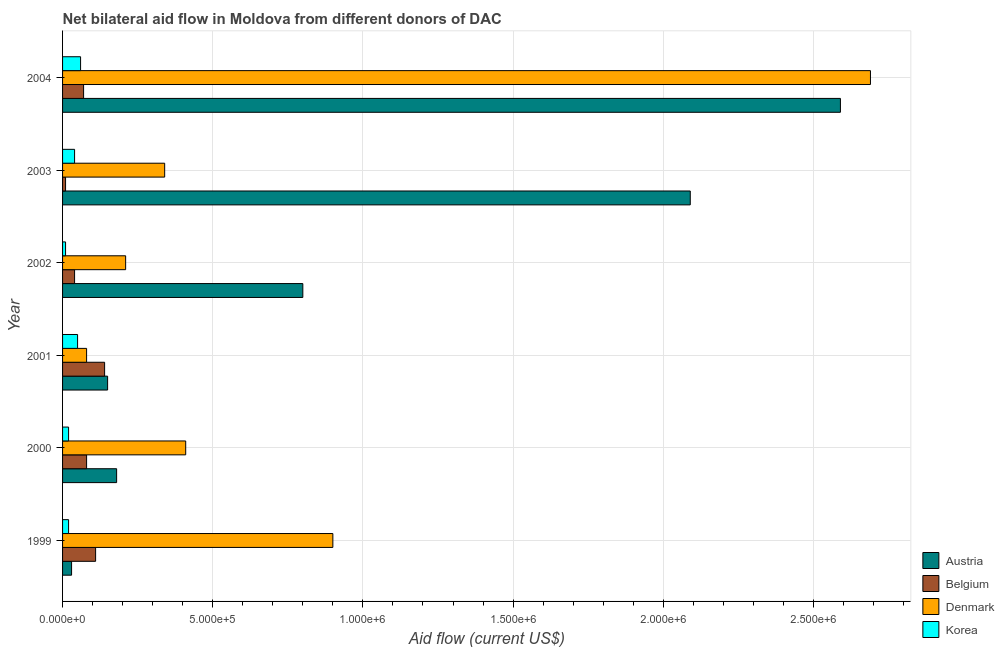How many bars are there on the 3rd tick from the top?
Your response must be concise. 4. What is the label of the 3rd group of bars from the top?
Your response must be concise. 2002. In how many cases, is the number of bars for a given year not equal to the number of legend labels?
Keep it short and to the point. 0. What is the amount of aid given by austria in 2002?
Make the answer very short. 8.00e+05. Across all years, what is the maximum amount of aid given by austria?
Your response must be concise. 2.59e+06. Across all years, what is the minimum amount of aid given by belgium?
Offer a very short reply. 10000. In which year was the amount of aid given by denmark maximum?
Provide a succinct answer. 2004. What is the total amount of aid given by korea in the graph?
Offer a terse response. 2.00e+05. What is the difference between the amount of aid given by denmark in 1999 and that in 2002?
Give a very brief answer. 6.90e+05. What is the difference between the amount of aid given by belgium in 2004 and the amount of aid given by denmark in 2002?
Provide a succinct answer. -1.40e+05. What is the average amount of aid given by belgium per year?
Your answer should be very brief. 7.50e+04. In the year 2004, what is the difference between the amount of aid given by belgium and amount of aid given by austria?
Provide a short and direct response. -2.52e+06. Is the difference between the amount of aid given by denmark in 1999 and 2004 greater than the difference between the amount of aid given by belgium in 1999 and 2004?
Your answer should be very brief. No. What is the difference between the highest and the second highest amount of aid given by denmark?
Give a very brief answer. 1.79e+06. What is the difference between the highest and the lowest amount of aid given by austria?
Keep it short and to the point. 2.56e+06. Is it the case that in every year, the sum of the amount of aid given by belgium and amount of aid given by austria is greater than the sum of amount of aid given by korea and amount of aid given by denmark?
Offer a very short reply. No. What does the 1st bar from the bottom in 1999 represents?
Offer a terse response. Austria. Is it the case that in every year, the sum of the amount of aid given by austria and amount of aid given by belgium is greater than the amount of aid given by denmark?
Offer a very short reply. No. Are the values on the major ticks of X-axis written in scientific E-notation?
Your answer should be very brief. Yes. Where does the legend appear in the graph?
Give a very brief answer. Bottom right. How many legend labels are there?
Make the answer very short. 4. How are the legend labels stacked?
Keep it short and to the point. Vertical. What is the title of the graph?
Give a very brief answer. Net bilateral aid flow in Moldova from different donors of DAC. Does "Oil" appear as one of the legend labels in the graph?
Your answer should be very brief. No. What is the label or title of the Y-axis?
Offer a terse response. Year. What is the Aid flow (current US$) in Austria in 1999?
Your response must be concise. 3.00e+04. What is the Aid flow (current US$) of Belgium in 1999?
Offer a very short reply. 1.10e+05. What is the Aid flow (current US$) in Denmark in 1999?
Provide a succinct answer. 9.00e+05. What is the Aid flow (current US$) of Belgium in 2000?
Your answer should be very brief. 8.00e+04. What is the Aid flow (current US$) in Denmark in 2000?
Your answer should be compact. 4.10e+05. What is the Aid flow (current US$) of Belgium in 2001?
Your answer should be very brief. 1.40e+05. What is the Aid flow (current US$) of Denmark in 2001?
Provide a succinct answer. 8.00e+04. What is the Aid flow (current US$) of Korea in 2001?
Provide a short and direct response. 5.00e+04. What is the Aid flow (current US$) in Austria in 2002?
Offer a very short reply. 8.00e+05. What is the Aid flow (current US$) of Belgium in 2002?
Offer a terse response. 4.00e+04. What is the Aid flow (current US$) of Korea in 2002?
Ensure brevity in your answer.  10000. What is the Aid flow (current US$) in Austria in 2003?
Ensure brevity in your answer.  2.09e+06. What is the Aid flow (current US$) of Denmark in 2003?
Give a very brief answer. 3.40e+05. What is the Aid flow (current US$) in Korea in 2003?
Offer a very short reply. 4.00e+04. What is the Aid flow (current US$) in Austria in 2004?
Offer a very short reply. 2.59e+06. What is the Aid flow (current US$) of Belgium in 2004?
Provide a succinct answer. 7.00e+04. What is the Aid flow (current US$) in Denmark in 2004?
Make the answer very short. 2.69e+06. What is the Aid flow (current US$) of Korea in 2004?
Your response must be concise. 6.00e+04. Across all years, what is the maximum Aid flow (current US$) in Austria?
Offer a very short reply. 2.59e+06. Across all years, what is the maximum Aid flow (current US$) of Denmark?
Ensure brevity in your answer.  2.69e+06. Across all years, what is the maximum Aid flow (current US$) in Korea?
Your answer should be compact. 6.00e+04. Across all years, what is the minimum Aid flow (current US$) in Austria?
Keep it short and to the point. 3.00e+04. Across all years, what is the minimum Aid flow (current US$) in Denmark?
Provide a short and direct response. 8.00e+04. Across all years, what is the minimum Aid flow (current US$) in Korea?
Provide a short and direct response. 10000. What is the total Aid flow (current US$) of Austria in the graph?
Your answer should be very brief. 5.84e+06. What is the total Aid flow (current US$) in Denmark in the graph?
Provide a succinct answer. 4.63e+06. What is the difference between the Aid flow (current US$) of Austria in 1999 and that in 2000?
Give a very brief answer. -1.50e+05. What is the difference between the Aid flow (current US$) of Korea in 1999 and that in 2000?
Offer a terse response. 0. What is the difference between the Aid flow (current US$) of Austria in 1999 and that in 2001?
Your answer should be compact. -1.20e+05. What is the difference between the Aid flow (current US$) of Belgium in 1999 and that in 2001?
Make the answer very short. -3.00e+04. What is the difference between the Aid flow (current US$) in Denmark in 1999 and that in 2001?
Your answer should be very brief. 8.20e+05. What is the difference between the Aid flow (current US$) of Korea in 1999 and that in 2001?
Give a very brief answer. -3.00e+04. What is the difference between the Aid flow (current US$) in Austria in 1999 and that in 2002?
Offer a terse response. -7.70e+05. What is the difference between the Aid flow (current US$) of Denmark in 1999 and that in 2002?
Your answer should be compact. 6.90e+05. What is the difference between the Aid flow (current US$) in Korea in 1999 and that in 2002?
Provide a short and direct response. 10000. What is the difference between the Aid flow (current US$) of Austria in 1999 and that in 2003?
Make the answer very short. -2.06e+06. What is the difference between the Aid flow (current US$) in Belgium in 1999 and that in 2003?
Keep it short and to the point. 1.00e+05. What is the difference between the Aid flow (current US$) of Denmark in 1999 and that in 2003?
Provide a short and direct response. 5.60e+05. What is the difference between the Aid flow (current US$) of Korea in 1999 and that in 2003?
Your answer should be very brief. -2.00e+04. What is the difference between the Aid flow (current US$) in Austria in 1999 and that in 2004?
Offer a very short reply. -2.56e+06. What is the difference between the Aid flow (current US$) in Denmark in 1999 and that in 2004?
Your response must be concise. -1.79e+06. What is the difference between the Aid flow (current US$) of Korea in 1999 and that in 2004?
Your response must be concise. -4.00e+04. What is the difference between the Aid flow (current US$) of Belgium in 2000 and that in 2001?
Your answer should be very brief. -6.00e+04. What is the difference between the Aid flow (current US$) of Denmark in 2000 and that in 2001?
Keep it short and to the point. 3.30e+05. What is the difference between the Aid flow (current US$) in Korea in 2000 and that in 2001?
Keep it short and to the point. -3.00e+04. What is the difference between the Aid flow (current US$) of Austria in 2000 and that in 2002?
Make the answer very short. -6.20e+05. What is the difference between the Aid flow (current US$) of Denmark in 2000 and that in 2002?
Provide a succinct answer. 2.00e+05. What is the difference between the Aid flow (current US$) of Austria in 2000 and that in 2003?
Provide a short and direct response. -1.91e+06. What is the difference between the Aid flow (current US$) of Austria in 2000 and that in 2004?
Provide a succinct answer. -2.41e+06. What is the difference between the Aid flow (current US$) in Denmark in 2000 and that in 2004?
Provide a succinct answer. -2.28e+06. What is the difference between the Aid flow (current US$) in Austria in 2001 and that in 2002?
Provide a succinct answer. -6.50e+05. What is the difference between the Aid flow (current US$) of Denmark in 2001 and that in 2002?
Your answer should be compact. -1.30e+05. What is the difference between the Aid flow (current US$) of Austria in 2001 and that in 2003?
Provide a succinct answer. -1.94e+06. What is the difference between the Aid flow (current US$) in Belgium in 2001 and that in 2003?
Your answer should be very brief. 1.30e+05. What is the difference between the Aid flow (current US$) in Austria in 2001 and that in 2004?
Provide a short and direct response. -2.44e+06. What is the difference between the Aid flow (current US$) of Belgium in 2001 and that in 2004?
Keep it short and to the point. 7.00e+04. What is the difference between the Aid flow (current US$) in Denmark in 2001 and that in 2004?
Provide a short and direct response. -2.61e+06. What is the difference between the Aid flow (current US$) of Korea in 2001 and that in 2004?
Offer a very short reply. -10000. What is the difference between the Aid flow (current US$) of Austria in 2002 and that in 2003?
Offer a terse response. -1.29e+06. What is the difference between the Aid flow (current US$) of Belgium in 2002 and that in 2003?
Provide a short and direct response. 3.00e+04. What is the difference between the Aid flow (current US$) of Austria in 2002 and that in 2004?
Provide a short and direct response. -1.79e+06. What is the difference between the Aid flow (current US$) in Belgium in 2002 and that in 2004?
Provide a succinct answer. -3.00e+04. What is the difference between the Aid flow (current US$) of Denmark in 2002 and that in 2004?
Your response must be concise. -2.48e+06. What is the difference between the Aid flow (current US$) in Korea in 2002 and that in 2004?
Make the answer very short. -5.00e+04. What is the difference between the Aid flow (current US$) in Austria in 2003 and that in 2004?
Make the answer very short. -5.00e+05. What is the difference between the Aid flow (current US$) of Denmark in 2003 and that in 2004?
Offer a very short reply. -2.35e+06. What is the difference between the Aid flow (current US$) of Austria in 1999 and the Aid flow (current US$) of Denmark in 2000?
Ensure brevity in your answer.  -3.80e+05. What is the difference between the Aid flow (current US$) of Belgium in 1999 and the Aid flow (current US$) of Korea in 2000?
Your response must be concise. 9.00e+04. What is the difference between the Aid flow (current US$) of Denmark in 1999 and the Aid flow (current US$) of Korea in 2000?
Keep it short and to the point. 8.80e+05. What is the difference between the Aid flow (current US$) of Austria in 1999 and the Aid flow (current US$) of Denmark in 2001?
Provide a short and direct response. -5.00e+04. What is the difference between the Aid flow (current US$) of Austria in 1999 and the Aid flow (current US$) of Korea in 2001?
Keep it short and to the point. -2.00e+04. What is the difference between the Aid flow (current US$) of Denmark in 1999 and the Aid flow (current US$) of Korea in 2001?
Offer a very short reply. 8.50e+05. What is the difference between the Aid flow (current US$) of Austria in 1999 and the Aid flow (current US$) of Belgium in 2002?
Provide a succinct answer. -10000. What is the difference between the Aid flow (current US$) in Denmark in 1999 and the Aid flow (current US$) in Korea in 2002?
Your answer should be very brief. 8.90e+05. What is the difference between the Aid flow (current US$) of Austria in 1999 and the Aid flow (current US$) of Denmark in 2003?
Give a very brief answer. -3.10e+05. What is the difference between the Aid flow (current US$) in Belgium in 1999 and the Aid flow (current US$) in Korea in 2003?
Make the answer very short. 7.00e+04. What is the difference between the Aid flow (current US$) of Denmark in 1999 and the Aid flow (current US$) of Korea in 2003?
Make the answer very short. 8.60e+05. What is the difference between the Aid flow (current US$) of Austria in 1999 and the Aid flow (current US$) of Belgium in 2004?
Your response must be concise. -4.00e+04. What is the difference between the Aid flow (current US$) in Austria in 1999 and the Aid flow (current US$) in Denmark in 2004?
Offer a terse response. -2.66e+06. What is the difference between the Aid flow (current US$) of Belgium in 1999 and the Aid flow (current US$) of Denmark in 2004?
Provide a succinct answer. -2.58e+06. What is the difference between the Aid flow (current US$) in Denmark in 1999 and the Aid flow (current US$) in Korea in 2004?
Make the answer very short. 8.40e+05. What is the difference between the Aid flow (current US$) of Austria in 2000 and the Aid flow (current US$) of Belgium in 2001?
Provide a short and direct response. 4.00e+04. What is the difference between the Aid flow (current US$) in Austria in 2000 and the Aid flow (current US$) in Korea in 2001?
Keep it short and to the point. 1.30e+05. What is the difference between the Aid flow (current US$) of Denmark in 2000 and the Aid flow (current US$) of Korea in 2001?
Offer a very short reply. 3.60e+05. What is the difference between the Aid flow (current US$) of Austria in 2000 and the Aid flow (current US$) of Belgium in 2002?
Ensure brevity in your answer.  1.40e+05. What is the difference between the Aid flow (current US$) in Austria in 2000 and the Aid flow (current US$) in Denmark in 2002?
Make the answer very short. -3.00e+04. What is the difference between the Aid flow (current US$) of Belgium in 2000 and the Aid flow (current US$) of Denmark in 2002?
Your answer should be very brief. -1.30e+05. What is the difference between the Aid flow (current US$) of Belgium in 2000 and the Aid flow (current US$) of Korea in 2002?
Ensure brevity in your answer.  7.00e+04. What is the difference between the Aid flow (current US$) in Denmark in 2000 and the Aid flow (current US$) in Korea in 2002?
Your answer should be compact. 4.00e+05. What is the difference between the Aid flow (current US$) in Austria in 2000 and the Aid flow (current US$) in Korea in 2003?
Provide a short and direct response. 1.40e+05. What is the difference between the Aid flow (current US$) of Belgium in 2000 and the Aid flow (current US$) of Korea in 2003?
Your answer should be compact. 4.00e+04. What is the difference between the Aid flow (current US$) of Austria in 2000 and the Aid flow (current US$) of Denmark in 2004?
Give a very brief answer. -2.51e+06. What is the difference between the Aid flow (current US$) in Austria in 2000 and the Aid flow (current US$) in Korea in 2004?
Offer a terse response. 1.20e+05. What is the difference between the Aid flow (current US$) of Belgium in 2000 and the Aid flow (current US$) of Denmark in 2004?
Offer a very short reply. -2.61e+06. What is the difference between the Aid flow (current US$) in Austria in 2001 and the Aid flow (current US$) in Belgium in 2002?
Provide a short and direct response. 1.10e+05. What is the difference between the Aid flow (current US$) in Belgium in 2001 and the Aid flow (current US$) in Denmark in 2002?
Your response must be concise. -7.00e+04. What is the difference between the Aid flow (current US$) of Belgium in 2001 and the Aid flow (current US$) of Korea in 2002?
Offer a very short reply. 1.30e+05. What is the difference between the Aid flow (current US$) of Denmark in 2001 and the Aid flow (current US$) of Korea in 2002?
Offer a very short reply. 7.00e+04. What is the difference between the Aid flow (current US$) in Austria in 2001 and the Aid flow (current US$) in Belgium in 2003?
Your answer should be compact. 1.40e+05. What is the difference between the Aid flow (current US$) in Austria in 2001 and the Aid flow (current US$) in Denmark in 2003?
Your answer should be very brief. -1.90e+05. What is the difference between the Aid flow (current US$) of Austria in 2001 and the Aid flow (current US$) of Korea in 2003?
Your answer should be very brief. 1.10e+05. What is the difference between the Aid flow (current US$) of Belgium in 2001 and the Aid flow (current US$) of Korea in 2003?
Your response must be concise. 1.00e+05. What is the difference between the Aid flow (current US$) of Austria in 2001 and the Aid flow (current US$) of Belgium in 2004?
Your answer should be very brief. 8.00e+04. What is the difference between the Aid flow (current US$) in Austria in 2001 and the Aid flow (current US$) in Denmark in 2004?
Provide a short and direct response. -2.54e+06. What is the difference between the Aid flow (current US$) in Belgium in 2001 and the Aid flow (current US$) in Denmark in 2004?
Offer a very short reply. -2.55e+06. What is the difference between the Aid flow (current US$) of Belgium in 2001 and the Aid flow (current US$) of Korea in 2004?
Make the answer very short. 8.00e+04. What is the difference between the Aid flow (current US$) in Austria in 2002 and the Aid flow (current US$) in Belgium in 2003?
Keep it short and to the point. 7.90e+05. What is the difference between the Aid flow (current US$) of Austria in 2002 and the Aid flow (current US$) of Denmark in 2003?
Your answer should be compact. 4.60e+05. What is the difference between the Aid flow (current US$) of Austria in 2002 and the Aid flow (current US$) of Korea in 2003?
Your answer should be compact. 7.60e+05. What is the difference between the Aid flow (current US$) of Belgium in 2002 and the Aid flow (current US$) of Korea in 2003?
Keep it short and to the point. 0. What is the difference between the Aid flow (current US$) in Denmark in 2002 and the Aid flow (current US$) in Korea in 2003?
Give a very brief answer. 1.70e+05. What is the difference between the Aid flow (current US$) in Austria in 2002 and the Aid flow (current US$) in Belgium in 2004?
Your answer should be very brief. 7.30e+05. What is the difference between the Aid flow (current US$) of Austria in 2002 and the Aid flow (current US$) of Denmark in 2004?
Offer a very short reply. -1.89e+06. What is the difference between the Aid flow (current US$) in Austria in 2002 and the Aid flow (current US$) in Korea in 2004?
Offer a very short reply. 7.40e+05. What is the difference between the Aid flow (current US$) in Belgium in 2002 and the Aid flow (current US$) in Denmark in 2004?
Your answer should be compact. -2.65e+06. What is the difference between the Aid flow (current US$) of Denmark in 2002 and the Aid flow (current US$) of Korea in 2004?
Your answer should be compact. 1.50e+05. What is the difference between the Aid flow (current US$) of Austria in 2003 and the Aid flow (current US$) of Belgium in 2004?
Provide a short and direct response. 2.02e+06. What is the difference between the Aid flow (current US$) of Austria in 2003 and the Aid flow (current US$) of Denmark in 2004?
Provide a short and direct response. -6.00e+05. What is the difference between the Aid flow (current US$) of Austria in 2003 and the Aid flow (current US$) of Korea in 2004?
Provide a short and direct response. 2.03e+06. What is the difference between the Aid flow (current US$) in Belgium in 2003 and the Aid flow (current US$) in Denmark in 2004?
Give a very brief answer. -2.68e+06. What is the difference between the Aid flow (current US$) of Belgium in 2003 and the Aid flow (current US$) of Korea in 2004?
Your response must be concise. -5.00e+04. What is the difference between the Aid flow (current US$) of Denmark in 2003 and the Aid flow (current US$) of Korea in 2004?
Offer a terse response. 2.80e+05. What is the average Aid flow (current US$) in Austria per year?
Your answer should be compact. 9.73e+05. What is the average Aid flow (current US$) in Belgium per year?
Keep it short and to the point. 7.50e+04. What is the average Aid flow (current US$) of Denmark per year?
Keep it short and to the point. 7.72e+05. What is the average Aid flow (current US$) of Korea per year?
Your answer should be compact. 3.33e+04. In the year 1999, what is the difference between the Aid flow (current US$) in Austria and Aid flow (current US$) in Belgium?
Your answer should be compact. -8.00e+04. In the year 1999, what is the difference between the Aid flow (current US$) of Austria and Aid flow (current US$) of Denmark?
Offer a very short reply. -8.70e+05. In the year 1999, what is the difference between the Aid flow (current US$) in Belgium and Aid flow (current US$) in Denmark?
Give a very brief answer. -7.90e+05. In the year 1999, what is the difference between the Aid flow (current US$) of Belgium and Aid flow (current US$) of Korea?
Your answer should be compact. 9.00e+04. In the year 1999, what is the difference between the Aid flow (current US$) of Denmark and Aid flow (current US$) of Korea?
Give a very brief answer. 8.80e+05. In the year 2000, what is the difference between the Aid flow (current US$) in Austria and Aid flow (current US$) in Belgium?
Your response must be concise. 1.00e+05. In the year 2000, what is the difference between the Aid flow (current US$) in Austria and Aid flow (current US$) in Denmark?
Offer a very short reply. -2.30e+05. In the year 2000, what is the difference between the Aid flow (current US$) in Austria and Aid flow (current US$) in Korea?
Keep it short and to the point. 1.60e+05. In the year 2000, what is the difference between the Aid flow (current US$) of Belgium and Aid flow (current US$) of Denmark?
Keep it short and to the point. -3.30e+05. In the year 2000, what is the difference between the Aid flow (current US$) of Denmark and Aid flow (current US$) of Korea?
Your response must be concise. 3.90e+05. In the year 2001, what is the difference between the Aid flow (current US$) of Austria and Aid flow (current US$) of Korea?
Your response must be concise. 1.00e+05. In the year 2001, what is the difference between the Aid flow (current US$) of Belgium and Aid flow (current US$) of Korea?
Offer a terse response. 9.00e+04. In the year 2002, what is the difference between the Aid flow (current US$) of Austria and Aid flow (current US$) of Belgium?
Make the answer very short. 7.60e+05. In the year 2002, what is the difference between the Aid flow (current US$) in Austria and Aid flow (current US$) in Denmark?
Offer a very short reply. 5.90e+05. In the year 2002, what is the difference between the Aid flow (current US$) in Austria and Aid flow (current US$) in Korea?
Provide a succinct answer. 7.90e+05. In the year 2002, what is the difference between the Aid flow (current US$) of Belgium and Aid flow (current US$) of Denmark?
Your answer should be compact. -1.70e+05. In the year 2002, what is the difference between the Aid flow (current US$) of Denmark and Aid flow (current US$) of Korea?
Keep it short and to the point. 2.00e+05. In the year 2003, what is the difference between the Aid flow (current US$) in Austria and Aid flow (current US$) in Belgium?
Give a very brief answer. 2.08e+06. In the year 2003, what is the difference between the Aid flow (current US$) in Austria and Aid flow (current US$) in Denmark?
Provide a short and direct response. 1.75e+06. In the year 2003, what is the difference between the Aid flow (current US$) in Austria and Aid flow (current US$) in Korea?
Your answer should be compact. 2.05e+06. In the year 2003, what is the difference between the Aid flow (current US$) in Belgium and Aid flow (current US$) in Denmark?
Provide a short and direct response. -3.30e+05. In the year 2003, what is the difference between the Aid flow (current US$) of Belgium and Aid flow (current US$) of Korea?
Your response must be concise. -3.00e+04. In the year 2003, what is the difference between the Aid flow (current US$) of Denmark and Aid flow (current US$) of Korea?
Offer a very short reply. 3.00e+05. In the year 2004, what is the difference between the Aid flow (current US$) of Austria and Aid flow (current US$) of Belgium?
Make the answer very short. 2.52e+06. In the year 2004, what is the difference between the Aid flow (current US$) of Austria and Aid flow (current US$) of Denmark?
Offer a terse response. -1.00e+05. In the year 2004, what is the difference between the Aid flow (current US$) in Austria and Aid flow (current US$) in Korea?
Your answer should be compact. 2.53e+06. In the year 2004, what is the difference between the Aid flow (current US$) in Belgium and Aid flow (current US$) in Denmark?
Your answer should be very brief. -2.62e+06. In the year 2004, what is the difference between the Aid flow (current US$) of Belgium and Aid flow (current US$) of Korea?
Offer a very short reply. 10000. In the year 2004, what is the difference between the Aid flow (current US$) in Denmark and Aid flow (current US$) in Korea?
Ensure brevity in your answer.  2.63e+06. What is the ratio of the Aid flow (current US$) in Belgium in 1999 to that in 2000?
Give a very brief answer. 1.38. What is the ratio of the Aid flow (current US$) of Denmark in 1999 to that in 2000?
Ensure brevity in your answer.  2.2. What is the ratio of the Aid flow (current US$) of Belgium in 1999 to that in 2001?
Offer a terse response. 0.79. What is the ratio of the Aid flow (current US$) in Denmark in 1999 to that in 2001?
Provide a short and direct response. 11.25. What is the ratio of the Aid flow (current US$) in Austria in 1999 to that in 2002?
Offer a very short reply. 0.04. What is the ratio of the Aid flow (current US$) of Belgium in 1999 to that in 2002?
Offer a very short reply. 2.75. What is the ratio of the Aid flow (current US$) of Denmark in 1999 to that in 2002?
Your answer should be compact. 4.29. What is the ratio of the Aid flow (current US$) of Austria in 1999 to that in 2003?
Your answer should be very brief. 0.01. What is the ratio of the Aid flow (current US$) of Denmark in 1999 to that in 2003?
Your response must be concise. 2.65. What is the ratio of the Aid flow (current US$) in Korea in 1999 to that in 2003?
Offer a terse response. 0.5. What is the ratio of the Aid flow (current US$) in Austria in 1999 to that in 2004?
Your answer should be compact. 0.01. What is the ratio of the Aid flow (current US$) in Belgium in 1999 to that in 2004?
Provide a succinct answer. 1.57. What is the ratio of the Aid flow (current US$) in Denmark in 1999 to that in 2004?
Your answer should be compact. 0.33. What is the ratio of the Aid flow (current US$) in Denmark in 2000 to that in 2001?
Offer a very short reply. 5.12. What is the ratio of the Aid flow (current US$) of Korea in 2000 to that in 2001?
Offer a terse response. 0.4. What is the ratio of the Aid flow (current US$) of Austria in 2000 to that in 2002?
Your answer should be very brief. 0.23. What is the ratio of the Aid flow (current US$) of Denmark in 2000 to that in 2002?
Keep it short and to the point. 1.95. What is the ratio of the Aid flow (current US$) in Austria in 2000 to that in 2003?
Provide a succinct answer. 0.09. What is the ratio of the Aid flow (current US$) of Denmark in 2000 to that in 2003?
Your response must be concise. 1.21. What is the ratio of the Aid flow (current US$) of Austria in 2000 to that in 2004?
Your response must be concise. 0.07. What is the ratio of the Aid flow (current US$) in Belgium in 2000 to that in 2004?
Provide a short and direct response. 1.14. What is the ratio of the Aid flow (current US$) in Denmark in 2000 to that in 2004?
Your answer should be compact. 0.15. What is the ratio of the Aid flow (current US$) of Korea in 2000 to that in 2004?
Keep it short and to the point. 0.33. What is the ratio of the Aid flow (current US$) in Austria in 2001 to that in 2002?
Offer a very short reply. 0.19. What is the ratio of the Aid flow (current US$) in Belgium in 2001 to that in 2002?
Your answer should be compact. 3.5. What is the ratio of the Aid flow (current US$) in Denmark in 2001 to that in 2002?
Your answer should be compact. 0.38. What is the ratio of the Aid flow (current US$) in Korea in 2001 to that in 2002?
Offer a terse response. 5. What is the ratio of the Aid flow (current US$) in Austria in 2001 to that in 2003?
Give a very brief answer. 0.07. What is the ratio of the Aid flow (current US$) in Denmark in 2001 to that in 2003?
Ensure brevity in your answer.  0.24. What is the ratio of the Aid flow (current US$) in Korea in 2001 to that in 2003?
Provide a succinct answer. 1.25. What is the ratio of the Aid flow (current US$) in Austria in 2001 to that in 2004?
Your answer should be compact. 0.06. What is the ratio of the Aid flow (current US$) of Denmark in 2001 to that in 2004?
Ensure brevity in your answer.  0.03. What is the ratio of the Aid flow (current US$) in Austria in 2002 to that in 2003?
Your answer should be very brief. 0.38. What is the ratio of the Aid flow (current US$) of Denmark in 2002 to that in 2003?
Ensure brevity in your answer.  0.62. What is the ratio of the Aid flow (current US$) in Austria in 2002 to that in 2004?
Give a very brief answer. 0.31. What is the ratio of the Aid flow (current US$) of Belgium in 2002 to that in 2004?
Make the answer very short. 0.57. What is the ratio of the Aid flow (current US$) in Denmark in 2002 to that in 2004?
Offer a terse response. 0.08. What is the ratio of the Aid flow (current US$) in Austria in 2003 to that in 2004?
Your answer should be very brief. 0.81. What is the ratio of the Aid flow (current US$) in Belgium in 2003 to that in 2004?
Make the answer very short. 0.14. What is the ratio of the Aid flow (current US$) of Denmark in 2003 to that in 2004?
Your response must be concise. 0.13. What is the difference between the highest and the second highest Aid flow (current US$) in Austria?
Give a very brief answer. 5.00e+05. What is the difference between the highest and the second highest Aid flow (current US$) in Belgium?
Provide a short and direct response. 3.00e+04. What is the difference between the highest and the second highest Aid flow (current US$) in Denmark?
Your answer should be very brief. 1.79e+06. What is the difference between the highest and the lowest Aid flow (current US$) of Austria?
Give a very brief answer. 2.56e+06. What is the difference between the highest and the lowest Aid flow (current US$) in Belgium?
Your answer should be very brief. 1.30e+05. What is the difference between the highest and the lowest Aid flow (current US$) in Denmark?
Offer a terse response. 2.61e+06. What is the difference between the highest and the lowest Aid flow (current US$) of Korea?
Ensure brevity in your answer.  5.00e+04. 